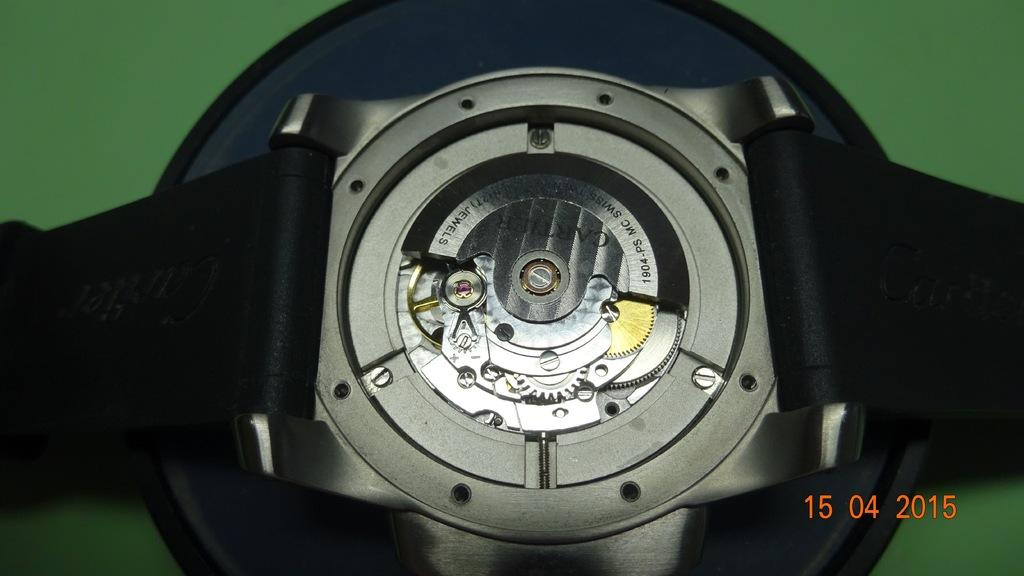<image>
Provide a brief description of the given image. The workings of a watch are shown with a 2015 time stamp in the corner. 